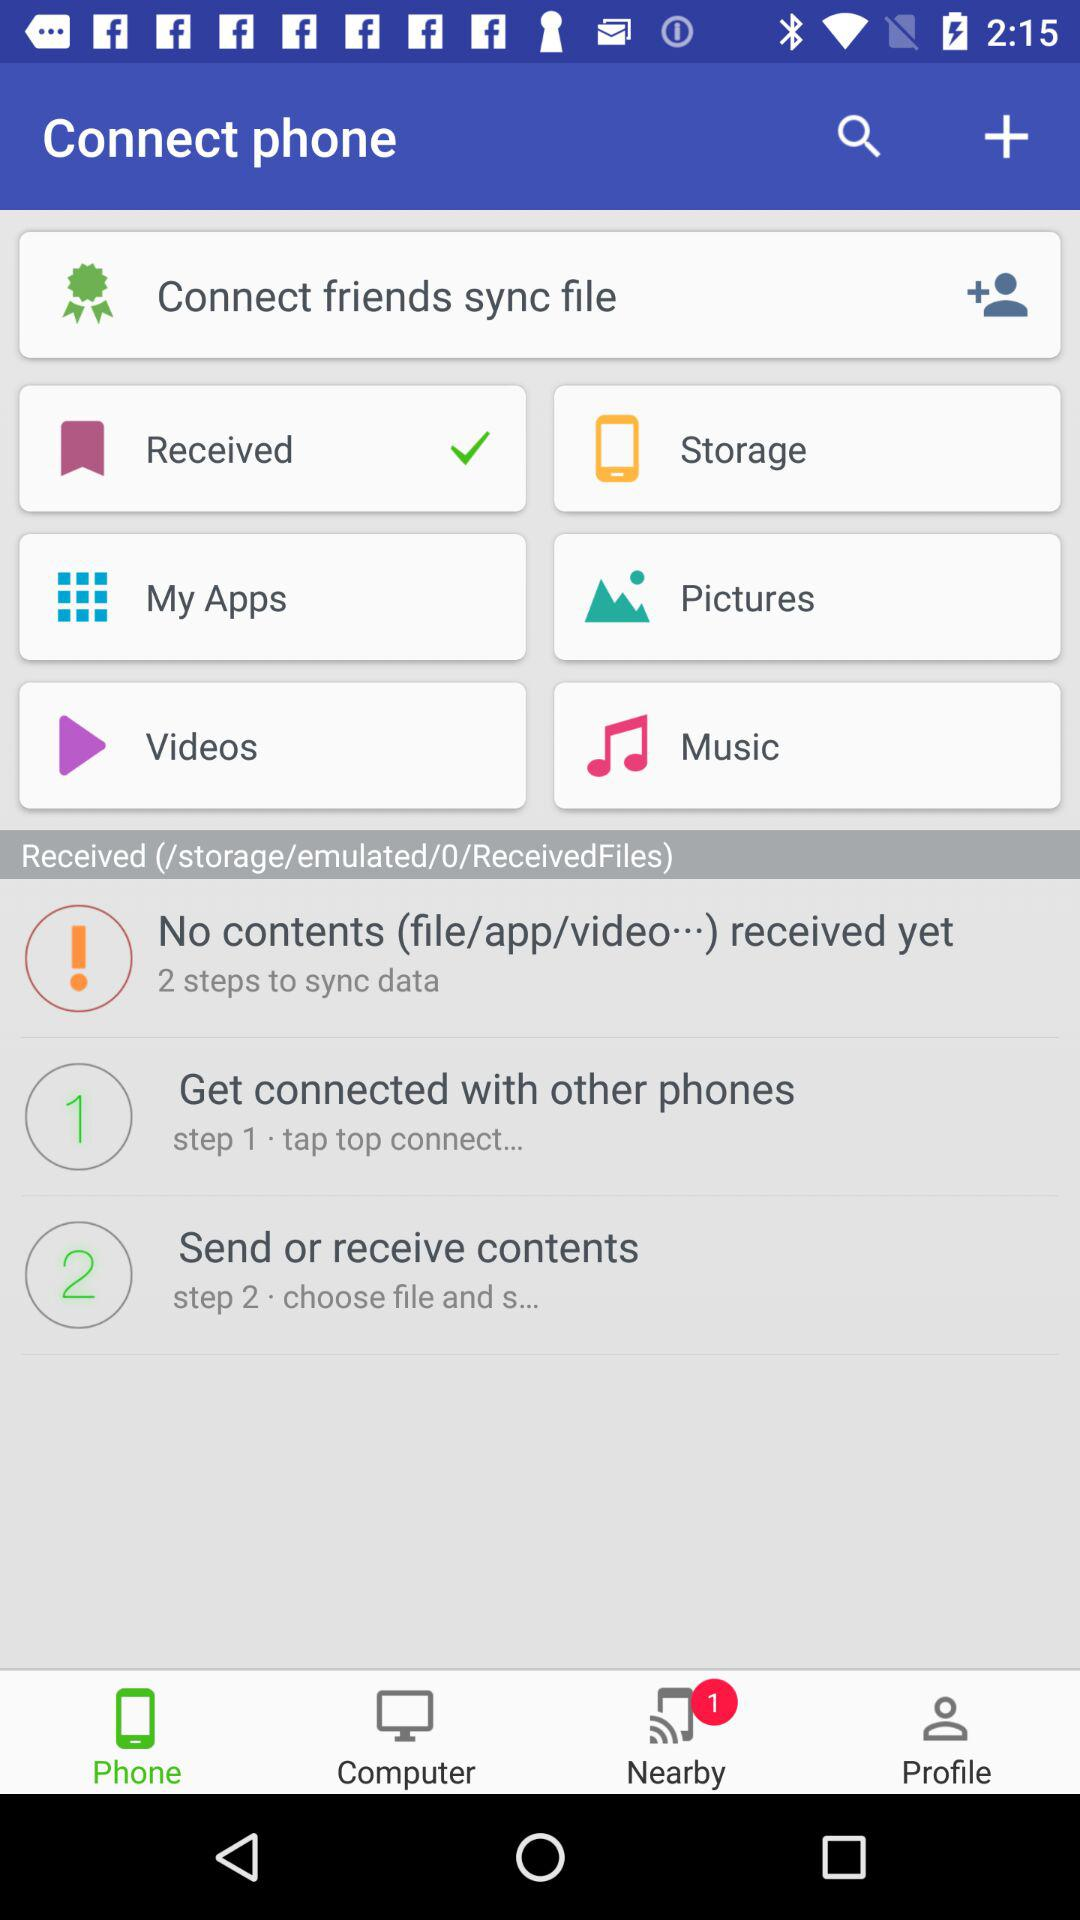Which choice has been marked as checked? The choice "Received" has been marked as checked. 